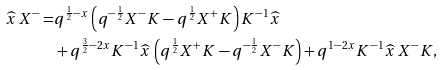<formula> <loc_0><loc_0><loc_500><loc_500>\widehat { x } \, X ^ { - } = & q ^ { \frac { 1 } { 2 } - x } \left ( q ^ { - \frac { 1 } { 2 } } X ^ { - } K - q ^ { \frac { 1 } { 2 } } X ^ { + } K \right ) K ^ { - 1 } \widehat { x } \\ & + q ^ { \frac { 3 } { 2 } - 2 x } K ^ { - 1 } \widehat { x } \, \left ( q ^ { \frac { 1 } { 2 } } X ^ { + } K - q ^ { - \frac { 1 } { 2 } } X ^ { - } K \right ) + q ^ { 1 - 2 x } K ^ { - 1 } \widehat { x } \, X ^ { - } K ,</formula> 